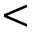<formula> <loc_0><loc_0><loc_500><loc_500><</formula> 